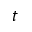Convert formula to latex. <formula><loc_0><loc_0><loc_500><loc_500>t</formula> 